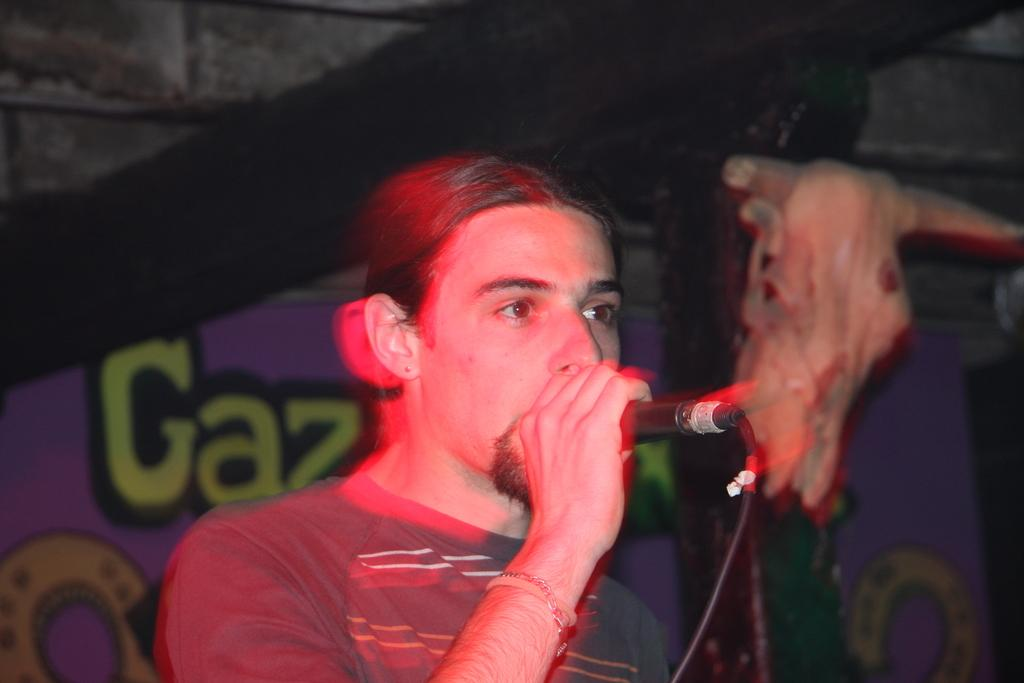Who is the main subject in the image? There is a man in the center of the image. What is the man holding in his hands? The man is holding a mic in his hands. What can be seen in the background of the image? There is a poster in the background of the image. What type of jeans is the man wearing in the image? There is no information about the man's jeans in the image, so we cannot determine the type of jeans he is wearing. 